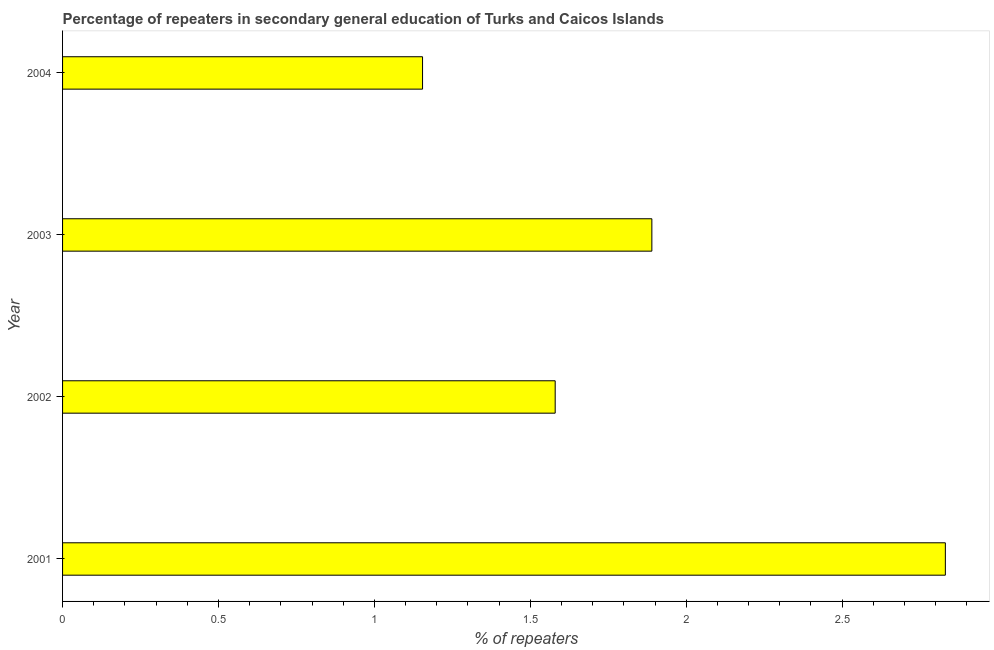What is the title of the graph?
Provide a succinct answer. Percentage of repeaters in secondary general education of Turks and Caicos Islands. What is the label or title of the X-axis?
Keep it short and to the point. % of repeaters. What is the percentage of repeaters in 2004?
Keep it short and to the point. 1.15. Across all years, what is the maximum percentage of repeaters?
Your answer should be compact. 2.83. Across all years, what is the minimum percentage of repeaters?
Provide a short and direct response. 1.15. In which year was the percentage of repeaters maximum?
Your answer should be very brief. 2001. In which year was the percentage of repeaters minimum?
Offer a very short reply. 2004. What is the sum of the percentage of repeaters?
Offer a terse response. 7.45. What is the difference between the percentage of repeaters in 2001 and 2004?
Ensure brevity in your answer.  1.68. What is the average percentage of repeaters per year?
Provide a succinct answer. 1.86. What is the median percentage of repeaters?
Provide a succinct answer. 1.73. In how many years, is the percentage of repeaters greater than 2.3 %?
Your answer should be compact. 1. Do a majority of the years between 2003 and 2001 (inclusive) have percentage of repeaters greater than 2.8 %?
Your response must be concise. Yes. What is the ratio of the percentage of repeaters in 2002 to that in 2003?
Keep it short and to the point. 0.84. Is the difference between the percentage of repeaters in 2002 and 2004 greater than the difference between any two years?
Keep it short and to the point. No. What is the difference between the highest and the second highest percentage of repeaters?
Give a very brief answer. 0.94. Is the sum of the percentage of repeaters in 2001 and 2004 greater than the maximum percentage of repeaters across all years?
Provide a short and direct response. Yes. What is the difference between the highest and the lowest percentage of repeaters?
Offer a very short reply. 1.68. What is the difference between two consecutive major ticks on the X-axis?
Provide a short and direct response. 0.5. Are the values on the major ticks of X-axis written in scientific E-notation?
Offer a terse response. No. What is the % of repeaters of 2001?
Make the answer very short. 2.83. What is the % of repeaters of 2002?
Ensure brevity in your answer.  1.58. What is the % of repeaters in 2003?
Provide a short and direct response. 1.89. What is the % of repeaters in 2004?
Give a very brief answer. 1.15. What is the difference between the % of repeaters in 2001 and 2002?
Provide a succinct answer. 1.25. What is the difference between the % of repeaters in 2001 and 2003?
Ensure brevity in your answer.  0.94. What is the difference between the % of repeaters in 2001 and 2004?
Offer a very short reply. 1.68. What is the difference between the % of repeaters in 2002 and 2003?
Offer a terse response. -0.31. What is the difference between the % of repeaters in 2002 and 2004?
Your answer should be compact. 0.43. What is the difference between the % of repeaters in 2003 and 2004?
Your answer should be compact. 0.74. What is the ratio of the % of repeaters in 2001 to that in 2002?
Your response must be concise. 1.79. What is the ratio of the % of repeaters in 2001 to that in 2003?
Your answer should be very brief. 1.5. What is the ratio of the % of repeaters in 2001 to that in 2004?
Your answer should be very brief. 2.45. What is the ratio of the % of repeaters in 2002 to that in 2003?
Give a very brief answer. 0.84. What is the ratio of the % of repeaters in 2002 to that in 2004?
Your answer should be very brief. 1.37. What is the ratio of the % of repeaters in 2003 to that in 2004?
Offer a very short reply. 1.64. 